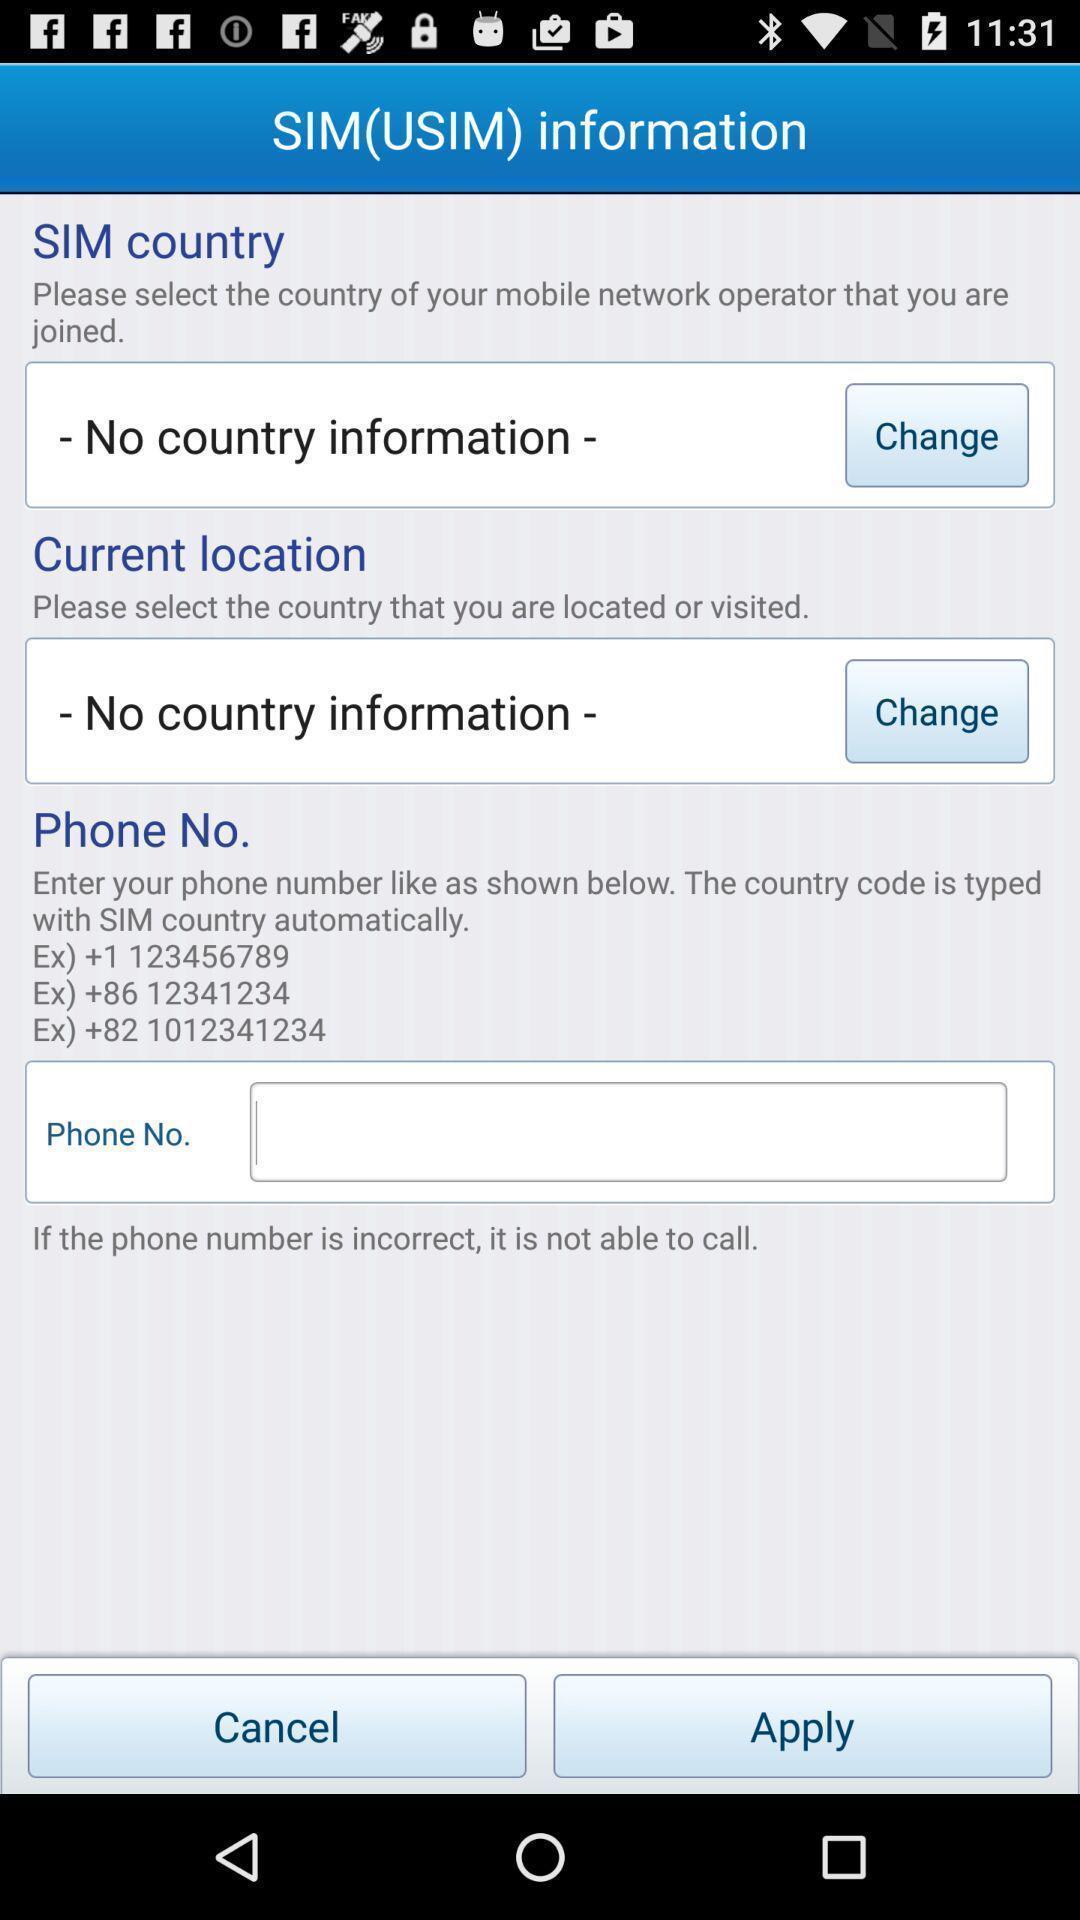What can you discern from this picture? Screen shows sim information page in the application. 